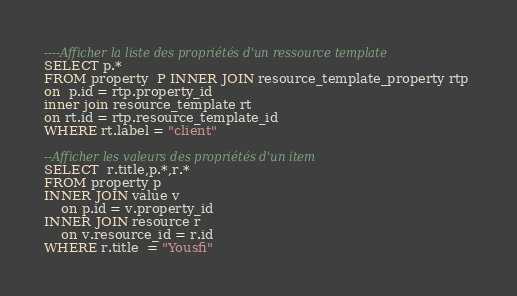Convert code to text. <code><loc_0><loc_0><loc_500><loc_500><_SQL_>----Afficher la liste des propriétés d'un ressource template
SELECT p.*
FROM property  P INNER JOIN resource_template_property rtp 
on  p.id = rtp.property_id
inner join resource_template rt
on rt.id = rtp.resource_template_id
WHERE rt.label = "client"

--Afficher les valeurs des propriétés d'un item
SELECT  r.title,p.*,r.*
FROM property p
INNER JOIN value v
    on p.id = v.property_id
INNER JOIN resource r
    on v.resource_id = r.id
WHERE r.title  = "Yousfi"












</code> 